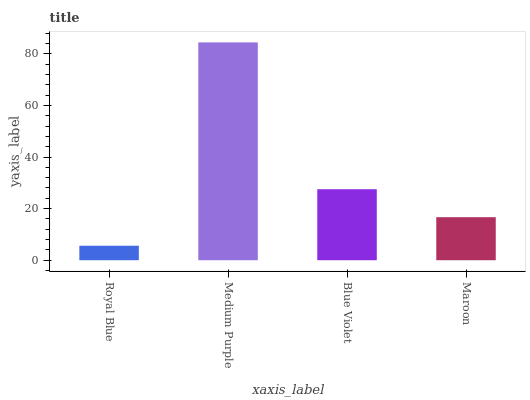Is Blue Violet the minimum?
Answer yes or no. No. Is Blue Violet the maximum?
Answer yes or no. No. Is Medium Purple greater than Blue Violet?
Answer yes or no. Yes. Is Blue Violet less than Medium Purple?
Answer yes or no. Yes. Is Blue Violet greater than Medium Purple?
Answer yes or no. No. Is Medium Purple less than Blue Violet?
Answer yes or no. No. Is Blue Violet the high median?
Answer yes or no. Yes. Is Maroon the low median?
Answer yes or no. Yes. Is Royal Blue the high median?
Answer yes or no. No. Is Medium Purple the low median?
Answer yes or no. No. 